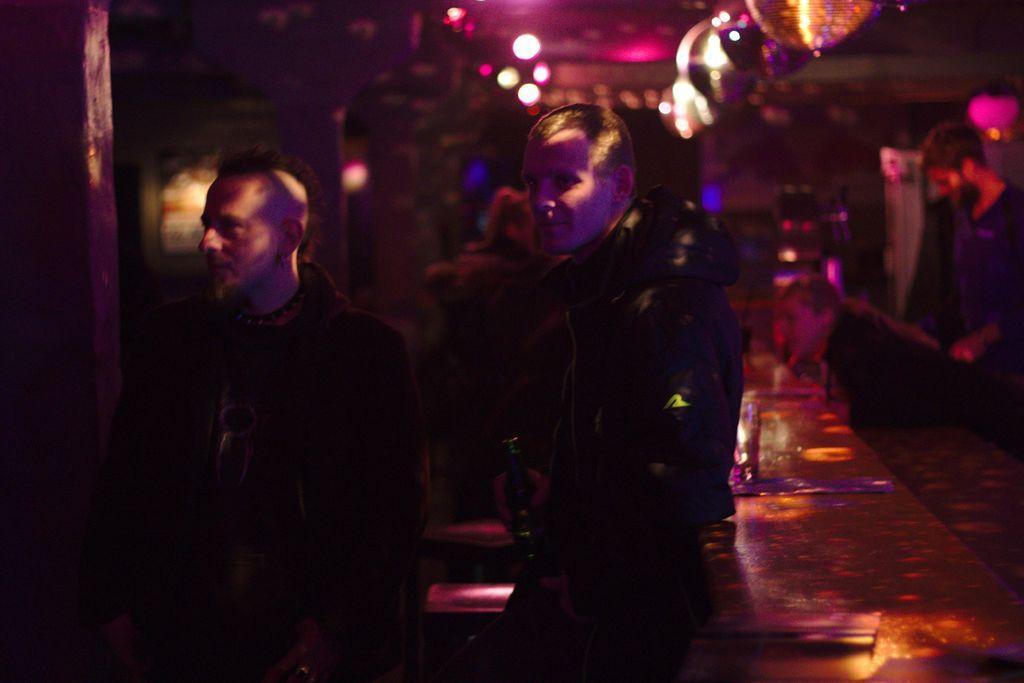Please provide a concise description of this image. In this image I can see few people are standing and in the front I can see two persons are wearing jackets. I can also see one of them is holding a bottle and in the background I can see number of lights. I can also see this image is little bit in dark. 